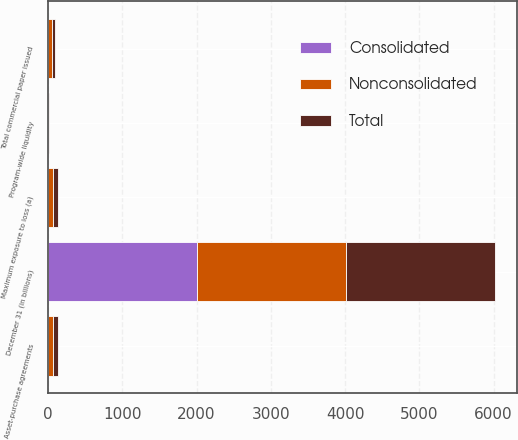<chart> <loc_0><loc_0><loc_500><loc_500><stacked_bar_chart><ecel><fcel>December 31 (in billions)<fcel>Total commercial paper issued<fcel>Asset-purchase agreements<fcel>Program-wide liquidity<fcel>Maximum exposure to loss (a)<nl><fcel>Consolidated<fcel>2006<fcel>3.4<fcel>0.5<fcel>1<fcel>1<nl><fcel>Nonconsolidated<fcel>2006<fcel>44.1<fcel>66<fcel>4<fcel>67<nl><fcel>Total<fcel>2006<fcel>47.5<fcel>66.5<fcel>5<fcel>68<nl></chart> 